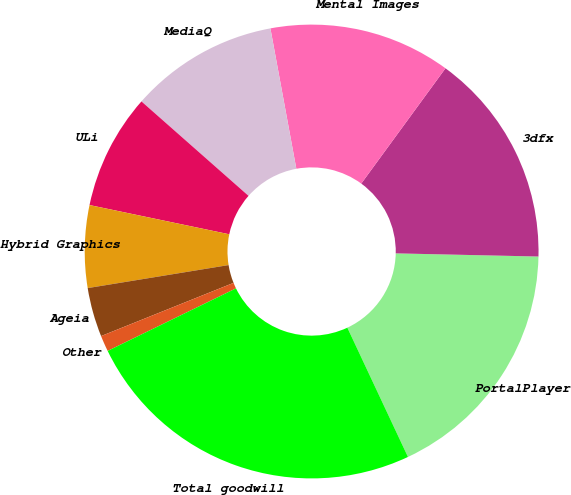Convert chart. <chart><loc_0><loc_0><loc_500><loc_500><pie_chart><fcel>PortalPlayer<fcel>3dfx<fcel>Mental Images<fcel>MediaQ<fcel>ULi<fcel>Hybrid Graphics<fcel>Ageia<fcel>Other<fcel>Total goodwill<nl><fcel>17.67%<fcel>15.31%<fcel>12.95%<fcel>10.59%<fcel>8.22%<fcel>5.86%<fcel>3.5%<fcel>1.14%<fcel>24.76%<nl></chart> 